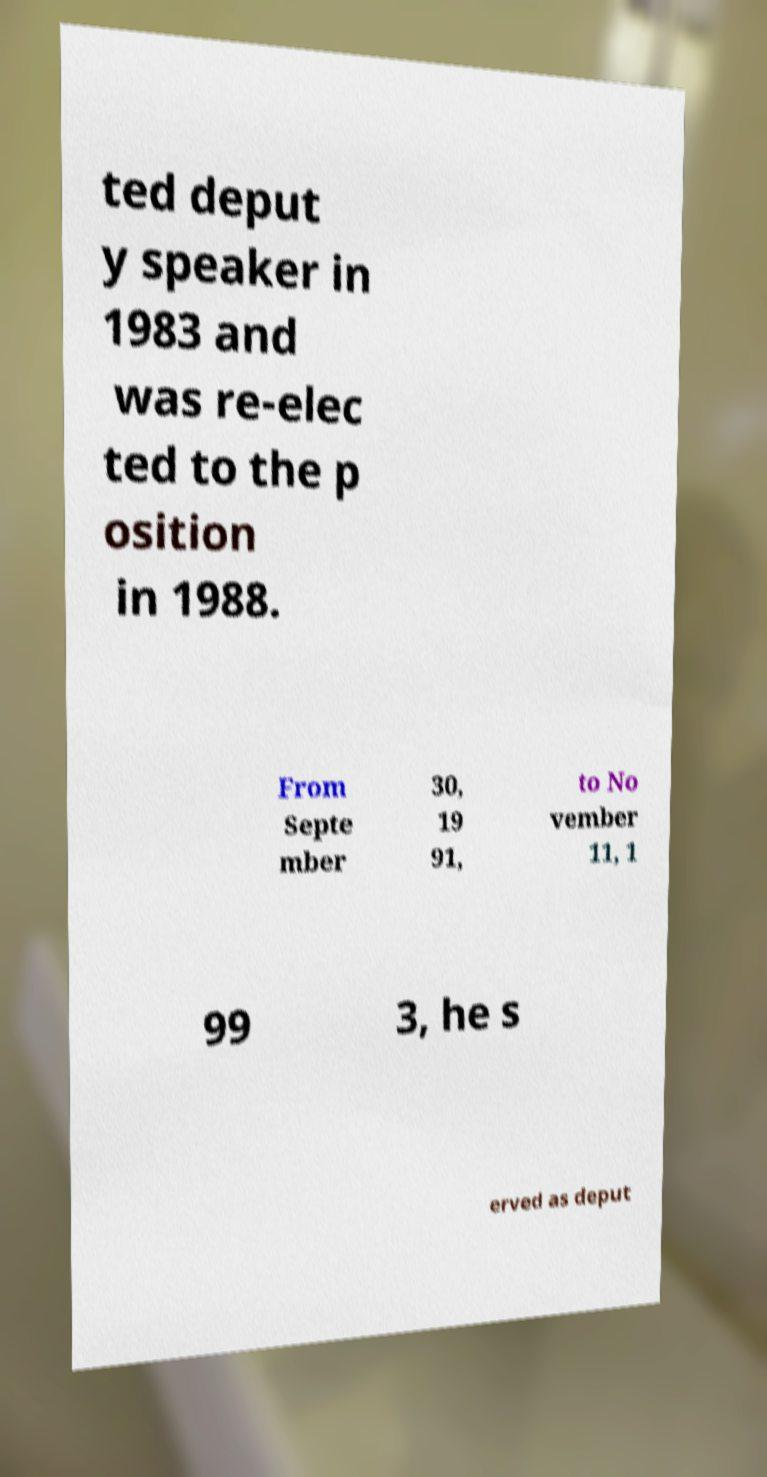For documentation purposes, I need the text within this image transcribed. Could you provide that? ted deput y speaker in 1983 and was re-elec ted to the p osition in 1988. From Septe mber 30, 19 91, to No vember 11, 1 99 3, he s erved as deput 